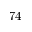Convert formula to latex. <formula><loc_0><loc_0><loc_500><loc_500>7 4</formula> 